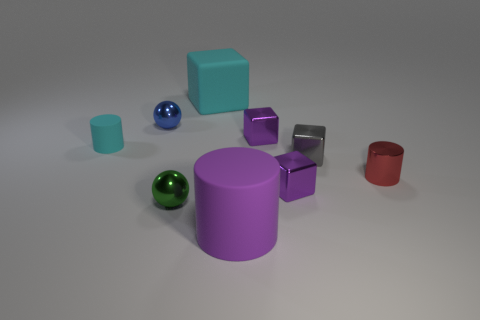Subtract all tiny metallic blocks. How many blocks are left? 1 Subtract all gray cylinders. How many purple cubes are left? 2 Subtract all cyan cubes. How many cubes are left? 3 Subtract 1 cubes. How many cubes are left? 3 Subtract all blue cubes. Subtract all gray balls. How many cubes are left? 4 Subtract all cylinders. How many objects are left? 6 Subtract all purple metal cubes. Subtract all cyan cylinders. How many objects are left? 6 Add 6 purple rubber objects. How many purple rubber objects are left? 7 Add 5 big balls. How many big balls exist? 5 Subtract 0 yellow blocks. How many objects are left? 9 